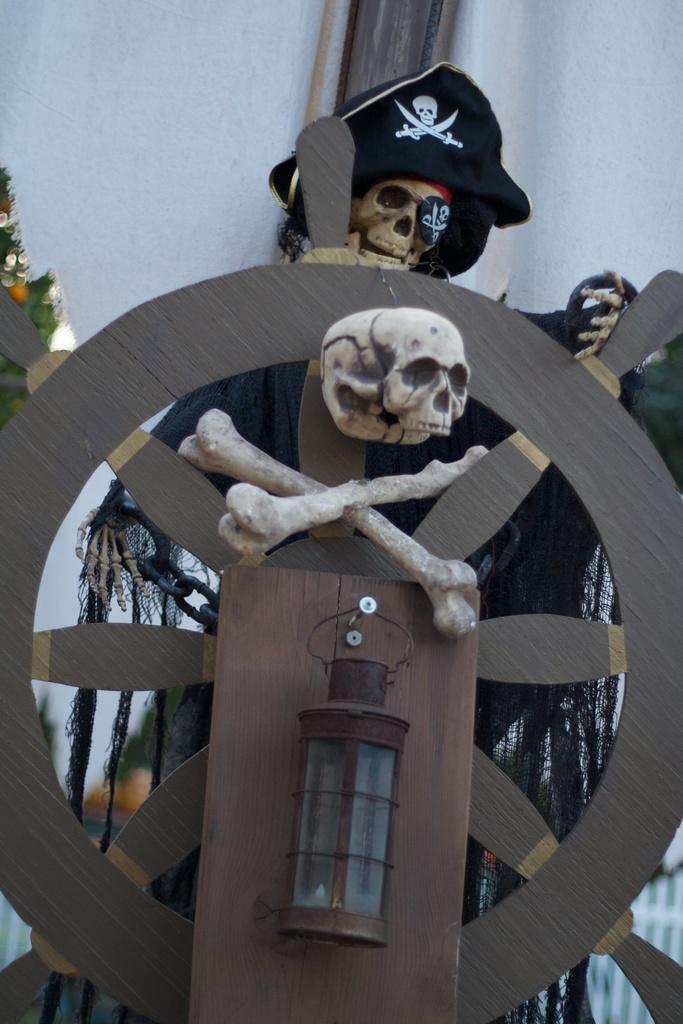Could you give a brief overview of what you see in this image? In this image we can see Panther, skulls, ship wheel, cap, chain and the wall in the background. 